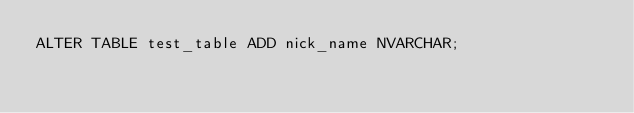<code> <loc_0><loc_0><loc_500><loc_500><_SQL_>ALTER TABLE test_table ADD nick_name NVARCHAR;</code> 